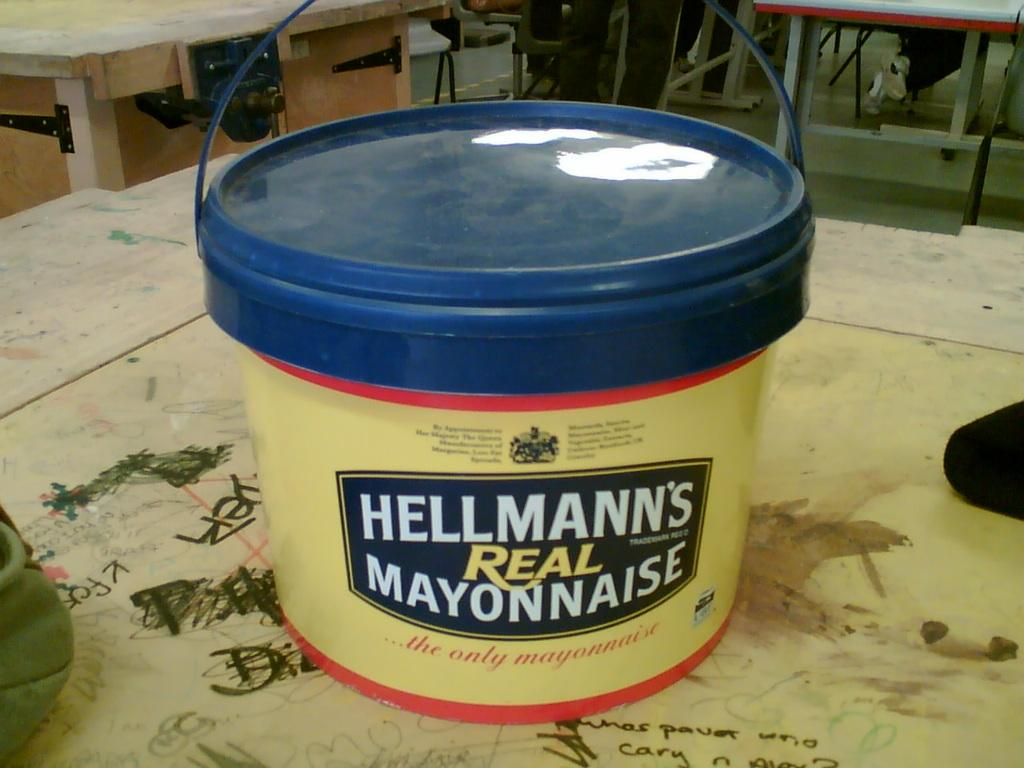What is placed on the table in the image? There is a bucket placed on a table in the image. What feature does the bucket have? The bucket has a lid. How can the bucket be carried or moved? The bucket has a handle for carrying or moving it. What can be seen in the background of the image? There are tables and people sitting in chairs in the background. What type of punishment is being administered to the banana in the image? There is no banana present in the image, and therefore no punishment can be observed. 